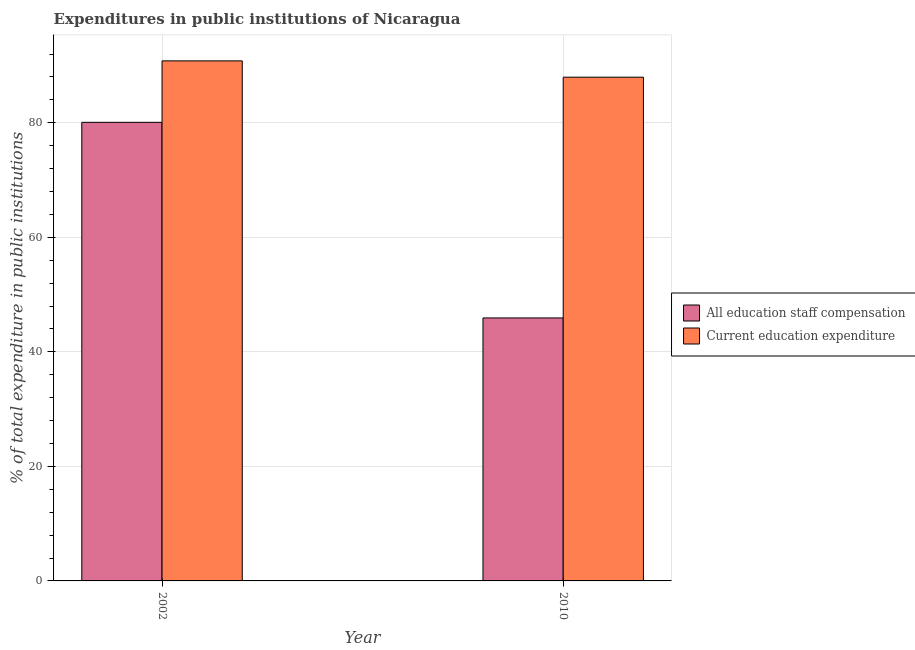How many different coloured bars are there?
Your answer should be compact. 2. Are the number of bars per tick equal to the number of legend labels?
Offer a terse response. Yes. Are the number of bars on each tick of the X-axis equal?
Provide a succinct answer. Yes. What is the expenditure in staff compensation in 2010?
Offer a terse response. 45.92. Across all years, what is the maximum expenditure in staff compensation?
Your response must be concise. 80.07. Across all years, what is the minimum expenditure in staff compensation?
Your answer should be very brief. 45.92. In which year was the expenditure in education maximum?
Provide a succinct answer. 2002. In which year was the expenditure in education minimum?
Offer a terse response. 2010. What is the total expenditure in staff compensation in the graph?
Your answer should be compact. 125.99. What is the difference between the expenditure in staff compensation in 2002 and that in 2010?
Offer a terse response. 34.16. What is the difference between the expenditure in staff compensation in 2010 and the expenditure in education in 2002?
Your answer should be very brief. -34.16. What is the average expenditure in staff compensation per year?
Offer a terse response. 63. In how many years, is the expenditure in education greater than 20 %?
Your response must be concise. 2. What is the ratio of the expenditure in staff compensation in 2002 to that in 2010?
Your answer should be compact. 1.74. In how many years, is the expenditure in staff compensation greater than the average expenditure in staff compensation taken over all years?
Give a very brief answer. 1. What does the 2nd bar from the left in 2002 represents?
Offer a terse response. Current education expenditure. What does the 2nd bar from the right in 2010 represents?
Offer a terse response. All education staff compensation. Are all the bars in the graph horizontal?
Offer a terse response. No. How many years are there in the graph?
Offer a terse response. 2. What is the difference between two consecutive major ticks on the Y-axis?
Provide a succinct answer. 20. Are the values on the major ticks of Y-axis written in scientific E-notation?
Provide a succinct answer. No. How many legend labels are there?
Offer a terse response. 2. How are the legend labels stacked?
Your response must be concise. Vertical. What is the title of the graph?
Keep it short and to the point. Expenditures in public institutions of Nicaragua. Does "Crop" appear as one of the legend labels in the graph?
Give a very brief answer. No. What is the label or title of the Y-axis?
Give a very brief answer. % of total expenditure in public institutions. What is the % of total expenditure in public institutions of All education staff compensation in 2002?
Keep it short and to the point. 80.07. What is the % of total expenditure in public institutions in Current education expenditure in 2002?
Offer a very short reply. 90.8. What is the % of total expenditure in public institutions of All education staff compensation in 2010?
Provide a short and direct response. 45.92. What is the % of total expenditure in public institutions of Current education expenditure in 2010?
Ensure brevity in your answer.  87.95. Across all years, what is the maximum % of total expenditure in public institutions in All education staff compensation?
Your answer should be very brief. 80.07. Across all years, what is the maximum % of total expenditure in public institutions of Current education expenditure?
Provide a succinct answer. 90.8. Across all years, what is the minimum % of total expenditure in public institutions in All education staff compensation?
Your answer should be compact. 45.92. Across all years, what is the minimum % of total expenditure in public institutions in Current education expenditure?
Keep it short and to the point. 87.95. What is the total % of total expenditure in public institutions of All education staff compensation in the graph?
Make the answer very short. 125.99. What is the total % of total expenditure in public institutions of Current education expenditure in the graph?
Your answer should be compact. 178.76. What is the difference between the % of total expenditure in public institutions of All education staff compensation in 2002 and that in 2010?
Provide a succinct answer. 34.16. What is the difference between the % of total expenditure in public institutions in Current education expenditure in 2002 and that in 2010?
Offer a very short reply. 2.85. What is the difference between the % of total expenditure in public institutions in All education staff compensation in 2002 and the % of total expenditure in public institutions in Current education expenditure in 2010?
Keep it short and to the point. -7.88. What is the average % of total expenditure in public institutions in All education staff compensation per year?
Keep it short and to the point. 63. What is the average % of total expenditure in public institutions in Current education expenditure per year?
Give a very brief answer. 89.38. In the year 2002, what is the difference between the % of total expenditure in public institutions of All education staff compensation and % of total expenditure in public institutions of Current education expenditure?
Ensure brevity in your answer.  -10.73. In the year 2010, what is the difference between the % of total expenditure in public institutions of All education staff compensation and % of total expenditure in public institutions of Current education expenditure?
Provide a short and direct response. -42.04. What is the ratio of the % of total expenditure in public institutions in All education staff compensation in 2002 to that in 2010?
Ensure brevity in your answer.  1.74. What is the ratio of the % of total expenditure in public institutions in Current education expenditure in 2002 to that in 2010?
Keep it short and to the point. 1.03. What is the difference between the highest and the second highest % of total expenditure in public institutions of All education staff compensation?
Keep it short and to the point. 34.16. What is the difference between the highest and the second highest % of total expenditure in public institutions in Current education expenditure?
Give a very brief answer. 2.85. What is the difference between the highest and the lowest % of total expenditure in public institutions in All education staff compensation?
Offer a terse response. 34.16. What is the difference between the highest and the lowest % of total expenditure in public institutions of Current education expenditure?
Your response must be concise. 2.85. 